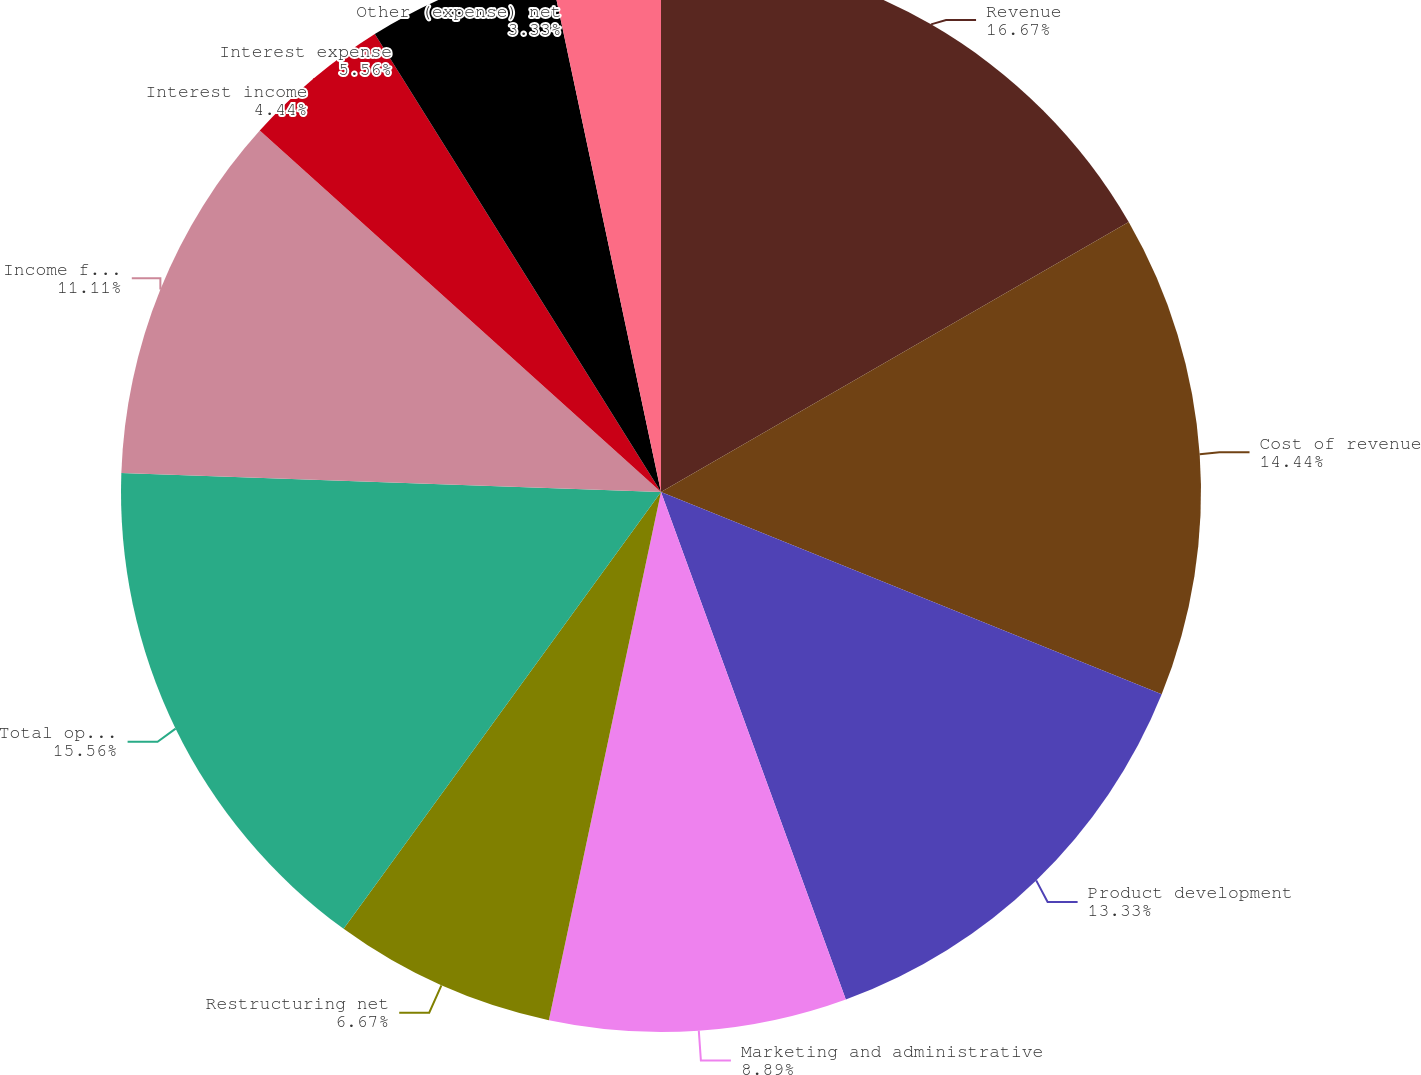Convert chart to OTSL. <chart><loc_0><loc_0><loc_500><loc_500><pie_chart><fcel>Revenue<fcel>Cost of revenue<fcel>Product development<fcel>Marketing and administrative<fcel>Restructuring net<fcel>Total operating expenses<fcel>Income from operations<fcel>Interest income<fcel>Interest expense<fcel>Other (expense) net<nl><fcel>16.67%<fcel>14.44%<fcel>13.33%<fcel>8.89%<fcel>6.67%<fcel>15.56%<fcel>11.11%<fcel>4.44%<fcel>5.56%<fcel>3.33%<nl></chart> 